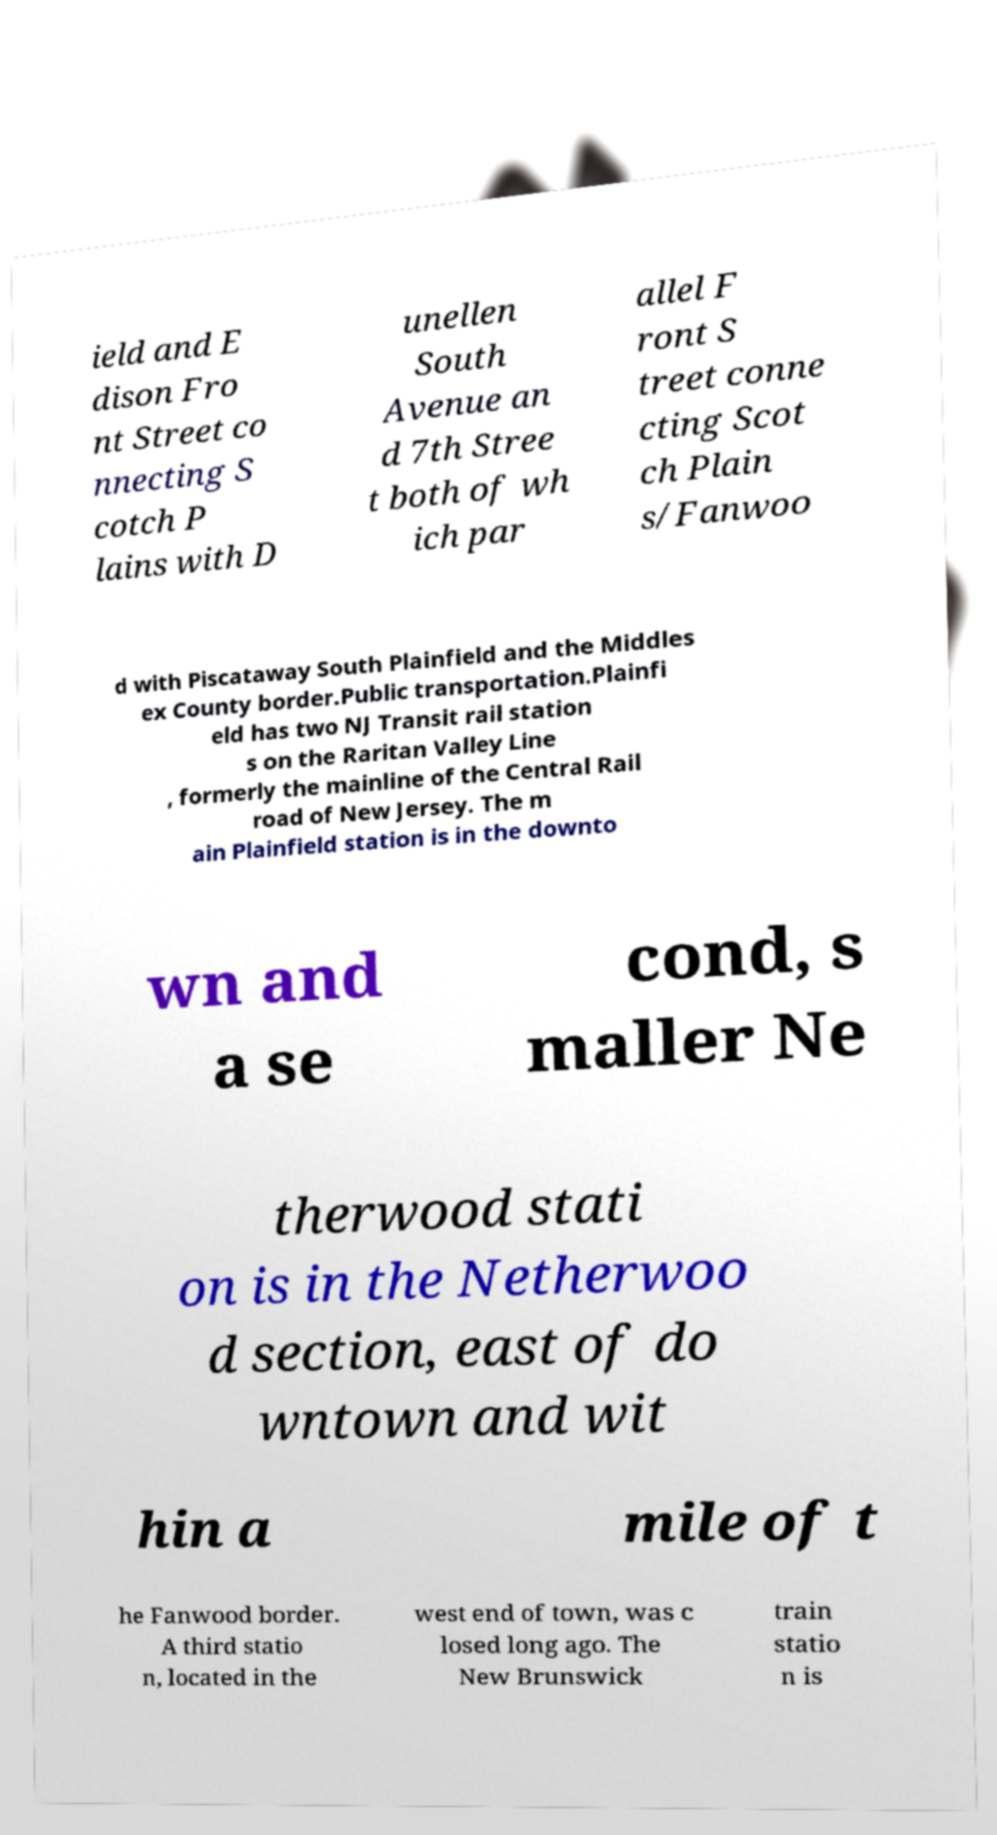There's text embedded in this image that I need extracted. Can you transcribe it verbatim? ield and E dison Fro nt Street co nnecting S cotch P lains with D unellen South Avenue an d 7th Stree t both of wh ich par allel F ront S treet conne cting Scot ch Plain s/Fanwoo d with Piscataway South Plainfield and the Middles ex County border.Public transportation.Plainfi eld has two NJ Transit rail station s on the Raritan Valley Line , formerly the mainline of the Central Rail road of New Jersey. The m ain Plainfield station is in the downto wn and a se cond, s maller Ne therwood stati on is in the Netherwoo d section, east of do wntown and wit hin a mile of t he Fanwood border. A third statio n, located in the west end of town, was c losed long ago. The New Brunswick train statio n is 